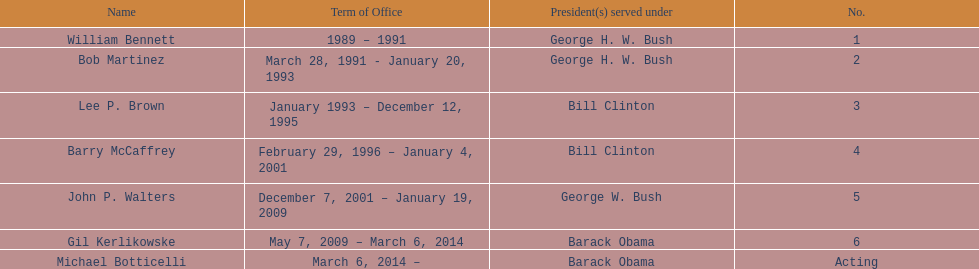Who was the succeeding appointed director post lee p. brown? Barry McCaffrey. 